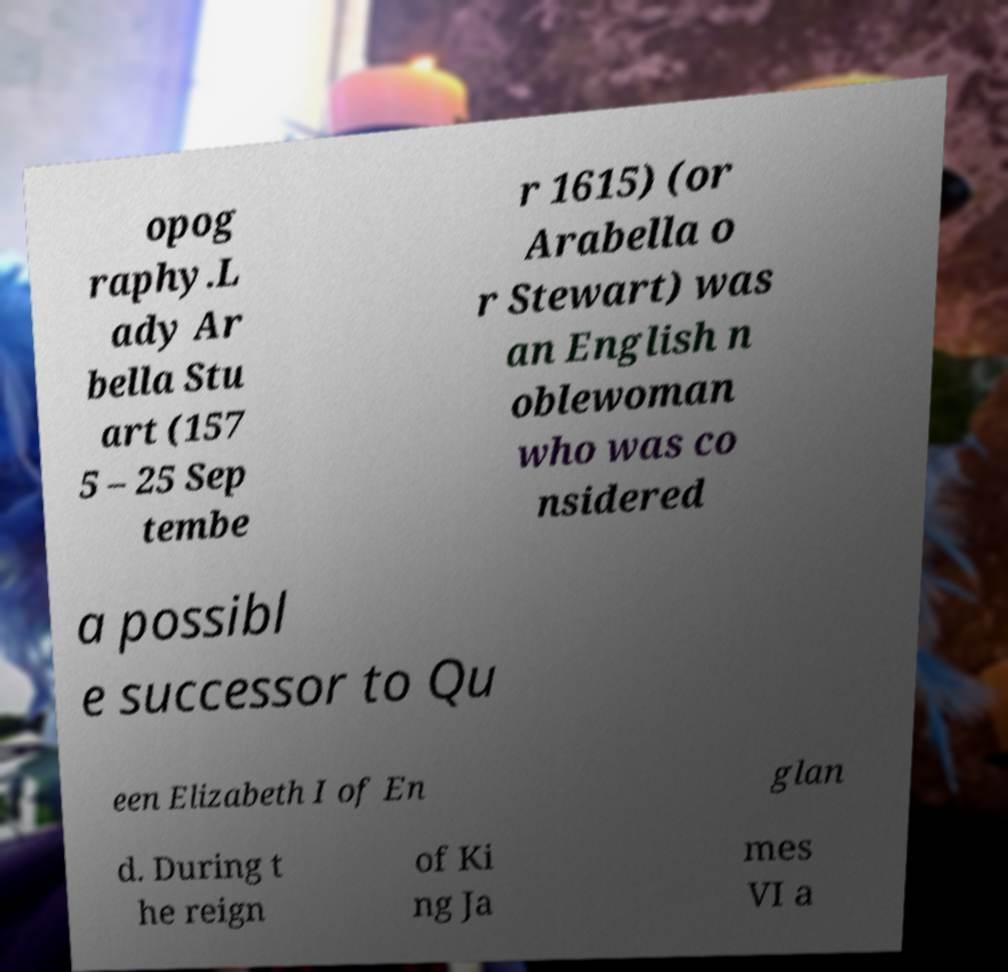For documentation purposes, I need the text within this image transcribed. Could you provide that? opog raphy.L ady Ar bella Stu art (157 5 – 25 Sep tembe r 1615) (or Arabella o r Stewart) was an English n oblewoman who was co nsidered a possibl e successor to Qu een Elizabeth I of En glan d. During t he reign of Ki ng Ja mes VI a 